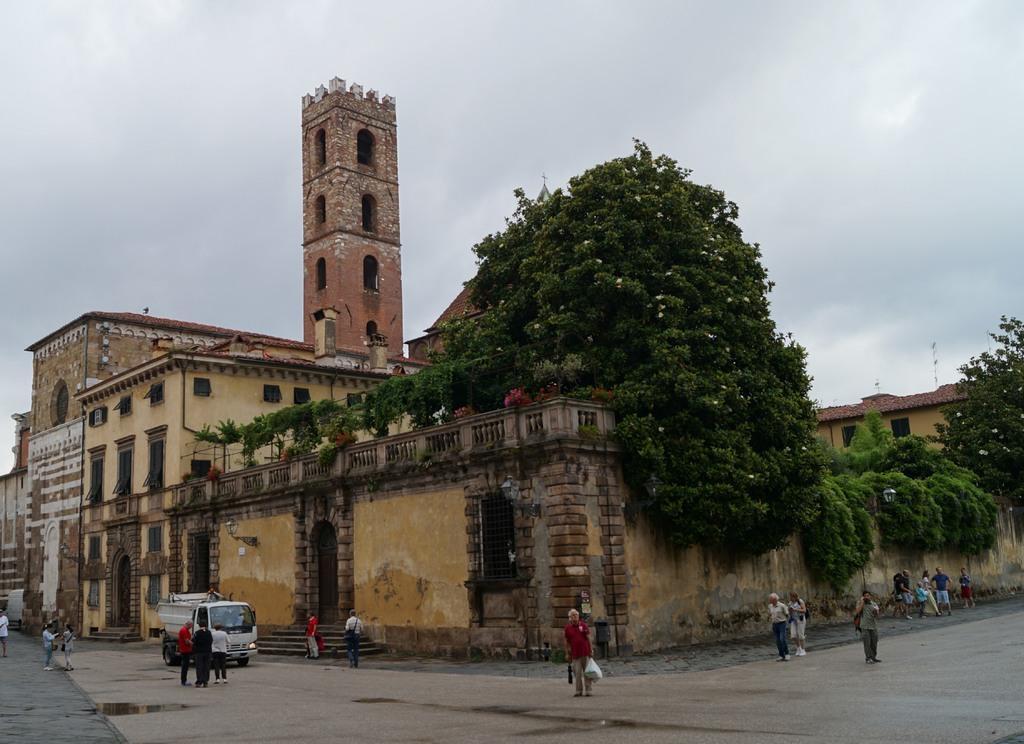Can you describe this image briefly? In this picture I can see the trees. I can see the vehicle on the surface. I can see the buildings on the right side. I can see a few people on the surface. I can see clouds in the sky. 